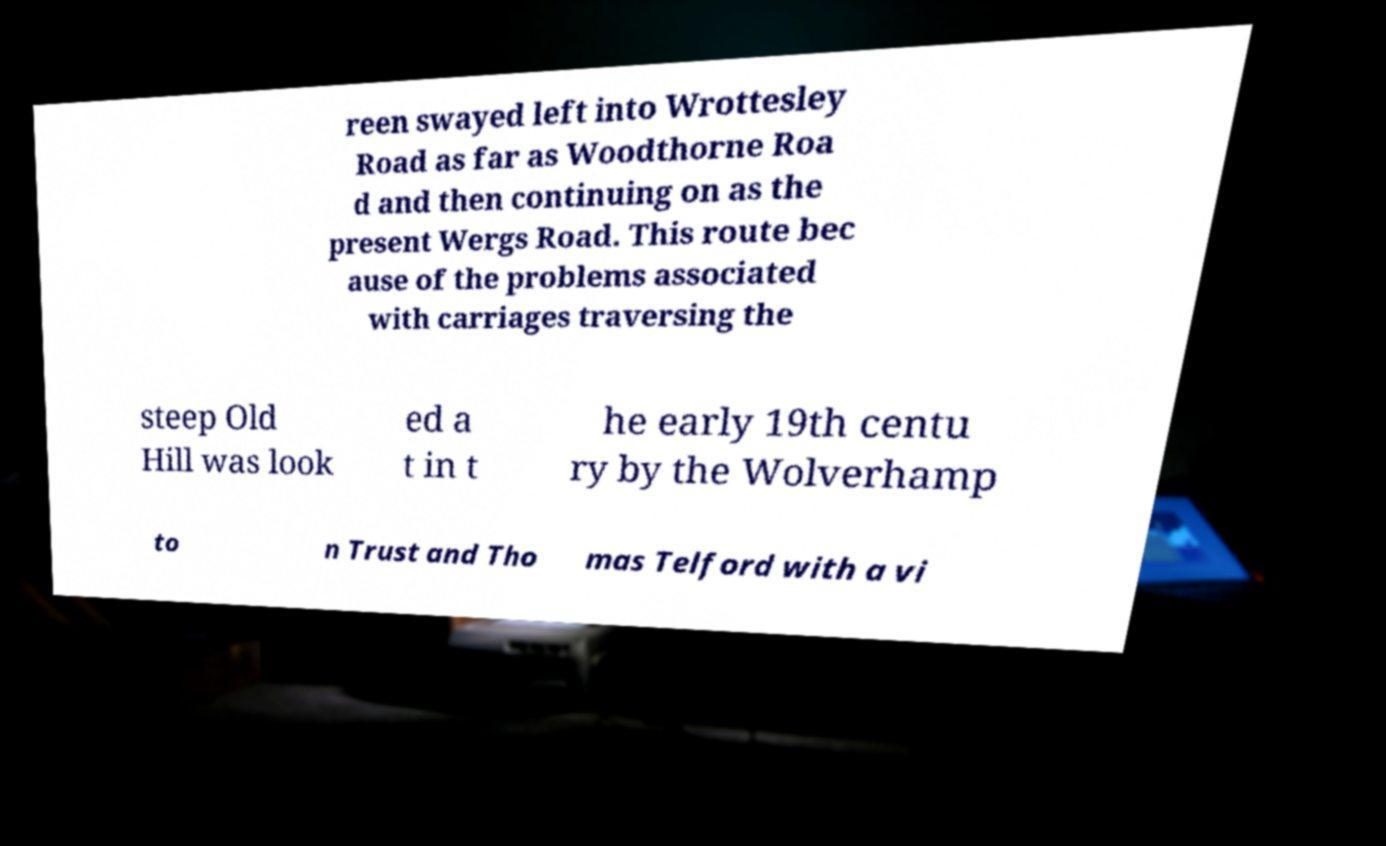Could you assist in decoding the text presented in this image and type it out clearly? reen swayed left into Wrottesley Road as far as Woodthorne Roa d and then continuing on as the present Wergs Road. This route bec ause of the problems associated with carriages traversing the steep Old Hill was look ed a t in t he early 19th centu ry by the Wolverhamp to n Trust and Tho mas Telford with a vi 